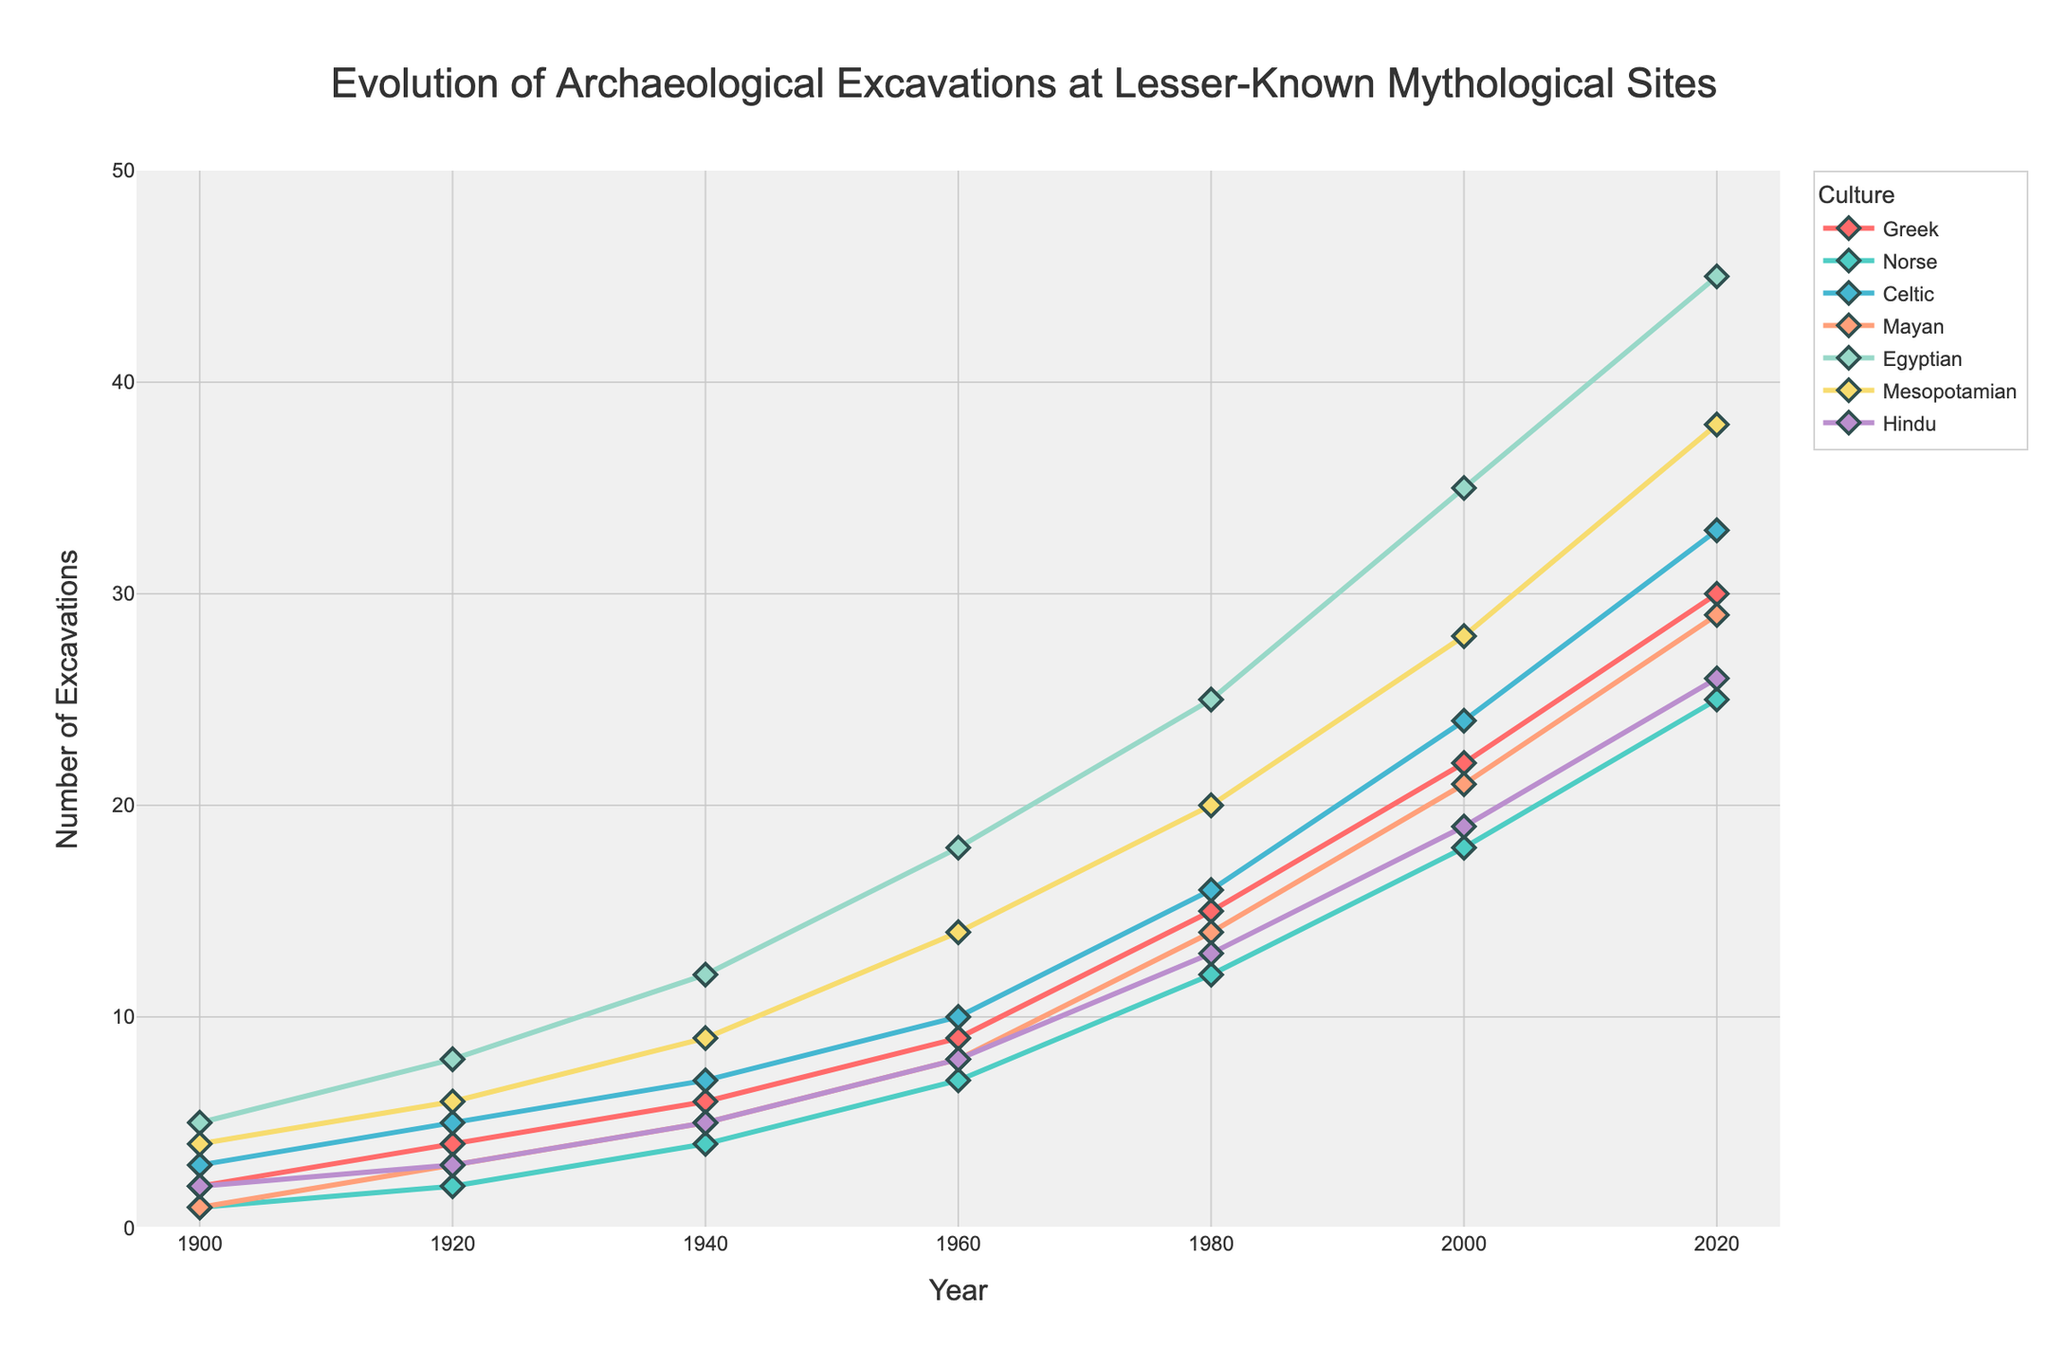Which culture had the highest number of excavations in 2020? By examining the year 2020 on the x-axis and comparing the heights of the lines for each culture, the Egyptian culture had the highest number of excavations.
Answer: Egyptian Which cultures had an equal number of excavations in 1900? By looking at the points at the year 1900 on the x-axis, the Greek and Hindu cultures both had 2 excavations.
Answer: Greek and Hindu What was the difference in the number of excavations between Mayan and Mesopotamian sites in 1960? Locate the points for Mayan and Mesopotamian cultures in 1960. Mayan had 8 excavations and Mesopotamian had 14. The difference is 14 - 8 = 6.
Answer: 6 Calculate the total number of excavations at Celtic sites from 1900 to 2020. Sum the values of Celtic sites over the years: 3 + 5 + 7 + 10 + 16 + 24 + 33 = 98.
Answer: 98 Which culture experienced the largest increase in excavations from 1900 to 2020? By comparing the heights of the lines from 1900 to 2020, the Egyptian culture showed the largest increase, from 5 to 45 excavations.
Answer: Egyptian Did the Hindu culture always have more excavations than the Norse culture from 1900 to 2020? Compare the values for Hindu and Norse cultures year by year: Hindu had 2, 3, 5, 8, 13, 19, and 26 excavations while Norse had 1, 2, 4, 7, 12, 18, and 25. Hindu had more excavations except in 1900.
Answer: No Which culture achieved the milestone of 10 excavations first and when? Identify the first occurrence of each culture's count reaching 10 or higher. Celtic was the first to reach 10 excavations in 1940.
Answer: Celtic in 1940 What was the average number of excavations for the Greek culture from 1900 to 2020? Calculate the mean of the Greek values over the years: (2 + 4 + 6 + 9 + 15 + 22 + 30) / 7 = 88 / 7 ≈ 12.57.
Answer: 12.57 Which two cultures had the closest number of excavations in 2000? Compare the values for each culture in 2000. Norse had 18 and Hindu had 19, which are the closest. The difference is 1.
Answer: Norse and Hindu 